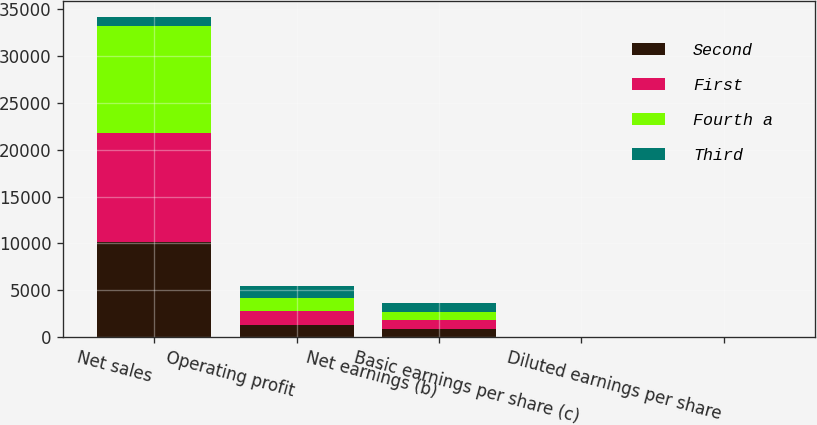<chart> <loc_0><loc_0><loc_500><loc_500><stacked_bar_chart><ecel><fcel>Net sales<fcel>Operating profit<fcel>Net earnings (b)<fcel>Basic earnings per share (c)<fcel>Diluted earnings per share<nl><fcel>Second<fcel>10111<fcel>1356<fcel>878<fcel>2.78<fcel>2.74<nl><fcel>First<fcel>11643<fcel>1445<fcel>929<fcel>2.98<fcel>2.94<nl><fcel>Fourth a<fcel>11461<fcel>1354<fcel>865<fcel>2.8<fcel>2.77<nl><fcel>Third<fcel>878<fcel>1281<fcel>933<fcel>3.05<fcel>3.01<nl></chart> 